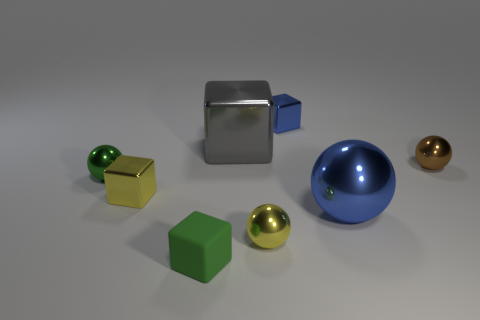There is a yellow shiny object that is the same shape as the big blue metallic object; what size is it?
Your answer should be compact. Small. There is a metal thing that is both behind the brown object and to the right of the big gray metallic object; what is its shape?
Your answer should be very brief. Cube. There is a yellow shiny sphere; does it have the same size as the shiny thing that is on the right side of the large blue sphere?
Your response must be concise. Yes. The other large metallic thing that is the same shape as the brown shiny object is what color?
Keep it short and to the point. Blue. There is a green object to the right of the tiny yellow block; is its size the same as the blue metal object in front of the small blue object?
Your response must be concise. No. Is the shape of the large blue thing the same as the tiny brown thing?
Give a very brief answer. Yes. How many things are either objects to the right of the large shiny ball or tiny cyan cylinders?
Your answer should be very brief. 1. Is there a small blue matte object of the same shape as the small green shiny object?
Ensure brevity in your answer.  No. Are there the same number of small green metallic objects behind the green sphere and brown balls?
Offer a terse response. No. What is the shape of the thing that is the same color as the small matte block?
Offer a very short reply. Sphere. 